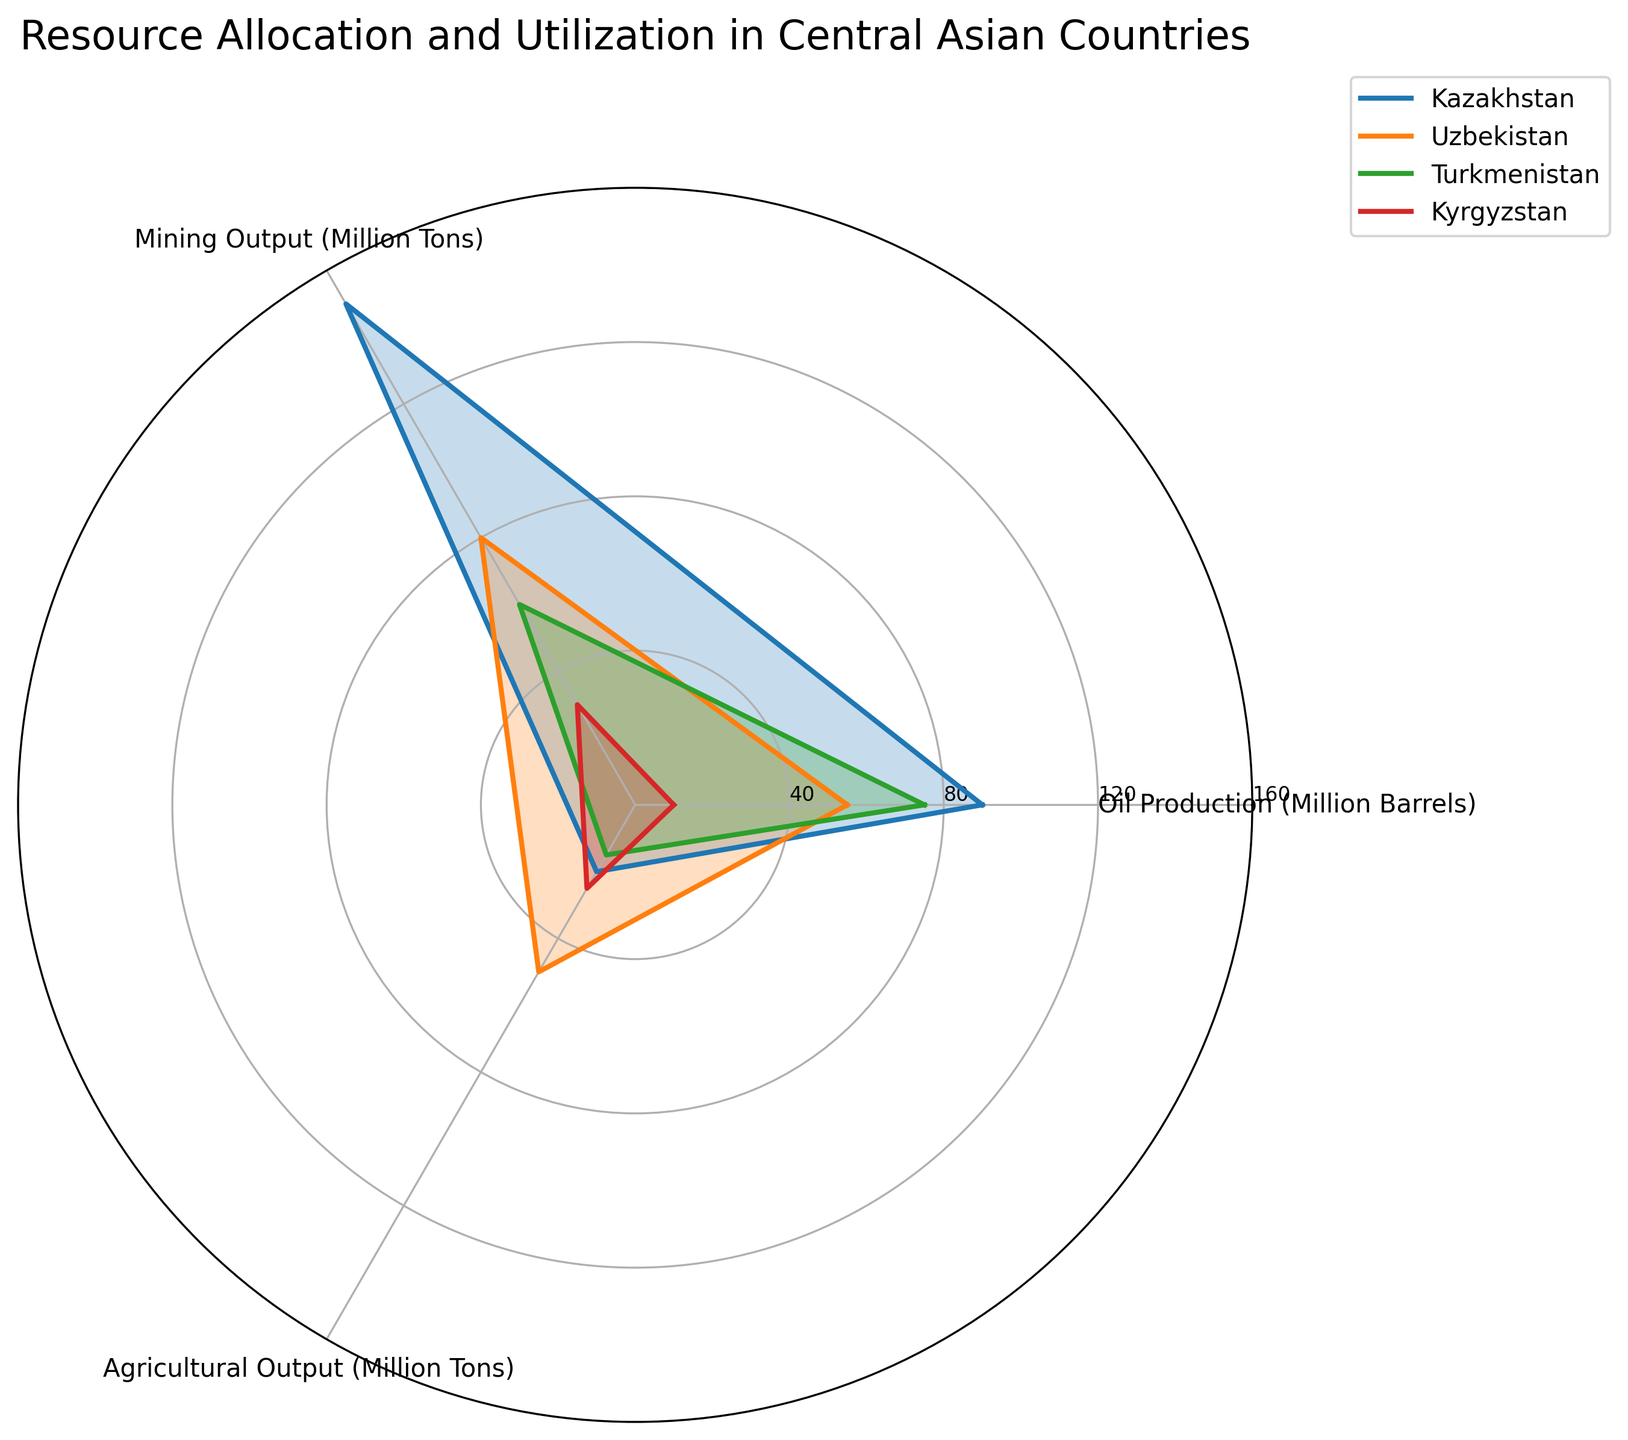Which country has the highest oil production? By examining the radar chart, look for the highest value on the oil production axis and identify the corresponding country. Kazakhstan is the country with the highest value for oil production at 90 million barrels, represented by the largest segment in the oil production category.
Answer: Kazakhstan Which country has the lowest mining output? Check the mining output axis on the radar chart and find the country with the smallest value. Kyrgyzstan has the lowest mining output, with 30 million tons. This is evident by the smallest segment length on the mining output axis.
Answer: Kyrgyzstan How much higher is Turkmenistan's oil production compared to Kyrgyzstan's? Identify Turkmenistan's and Kyrgyzstan's values in the oil production category on the radar chart. Turkmenistan has 75 million barrels and Kyrgyzstan has 10 million barrels. Subtract Kyrgyzstan's value from Turkmenistan's: 75 - 10 = 65 million barrels.
Answer: 65 million barrels Which country has the most balanced distribution across the three resources? Look at the radar chart for the country whose plot shows relatively even segment lengths in all three categories, indicating similar levels of production. Uzbekistan has the most balanced distribution with values of 55 (oil), 80 (mining), and 50 (agriculture), which are relatively close compared to other countries.
Answer: Uzbekistan What is the sum of agricultural output for Kazakhstan and Uzbekistan combined? Find the values for agricultural output for both Kazakhstan and Uzbekistan from the radar chart. Kazakhstan has 20 million tons and Uzbekistan has 50 million tons. Add these values: 20 + 50 = 70 million tons.
Answer: 70 million tons Is Uzbekistan's mining output higher than Turkmenistan's mining output? Compare the values for mining output for Uzbekistan and Turkmenistan on the radar chart. Uzbekistan has 80 million tons of mining output, while Turkmenistan has 60 million tons. Since 80 is greater than 60, Uzbekistan's mining output is higher.
Answer: Yes Rank the countries by their agricultural output from highest to lowest. Identify the agricultural output values from the radar chart and order them: Uzbekistan (50), Kyrgyzstan (25), Kazakhstan (20), and Turkmenistan (15). The ranking is as follows: Uzbekistan > Kyrgyzstan > Kazakhstan > Turkmenistan.
Answer: Uzbekistan, Kyrgyzstan, Kazakhstan, Turkmenistan Which category shows the most variation in outputs among the countries? Examine the range of values in each category on the radar chart. Agricultural output varies from 15 to 50 million tons, oil production ranges from 10 to 90 million barrels, and mining output ranges from 30 to 150 million tons. Mining output has the widest range (120 tons), indicating the most variation.
Answer: Mining output 